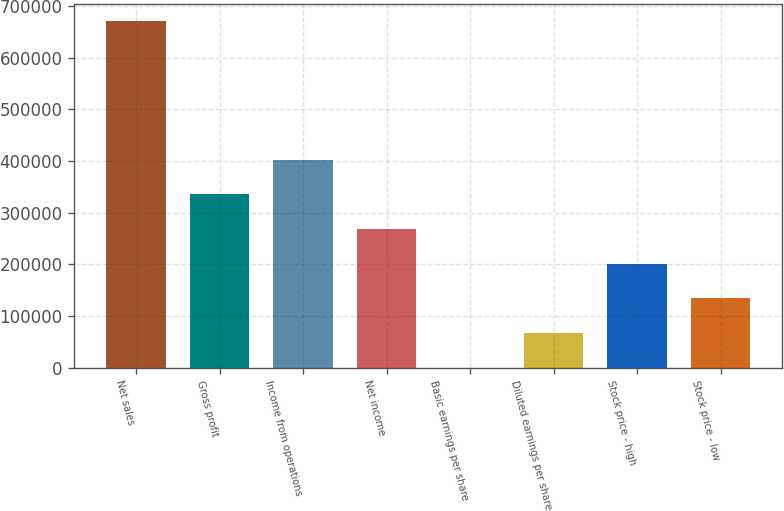Convert chart. <chart><loc_0><loc_0><loc_500><loc_500><bar_chart><fcel>Net sales<fcel>Gross profit<fcel>Income from operations<fcel>Net income<fcel>Basic earnings per share<fcel>Diluted earnings per share<fcel>Stock price - high<fcel>Stock price - low<nl><fcel>671357<fcel>335679<fcel>402814<fcel>268543<fcel>0.18<fcel>67135.9<fcel>201407<fcel>134272<nl></chart> 